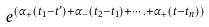Convert formula to latex. <formula><loc_0><loc_0><loc_500><loc_500>e ^ { ( \alpha _ { + } ( t _ { 1 } - t ^ { \prime } ) + \alpha _ { - } ( t _ { 2 } - t _ { 1 } ) + \cdots . + \alpha _ { + } ( t - t _ { n } ) ) }</formula> 